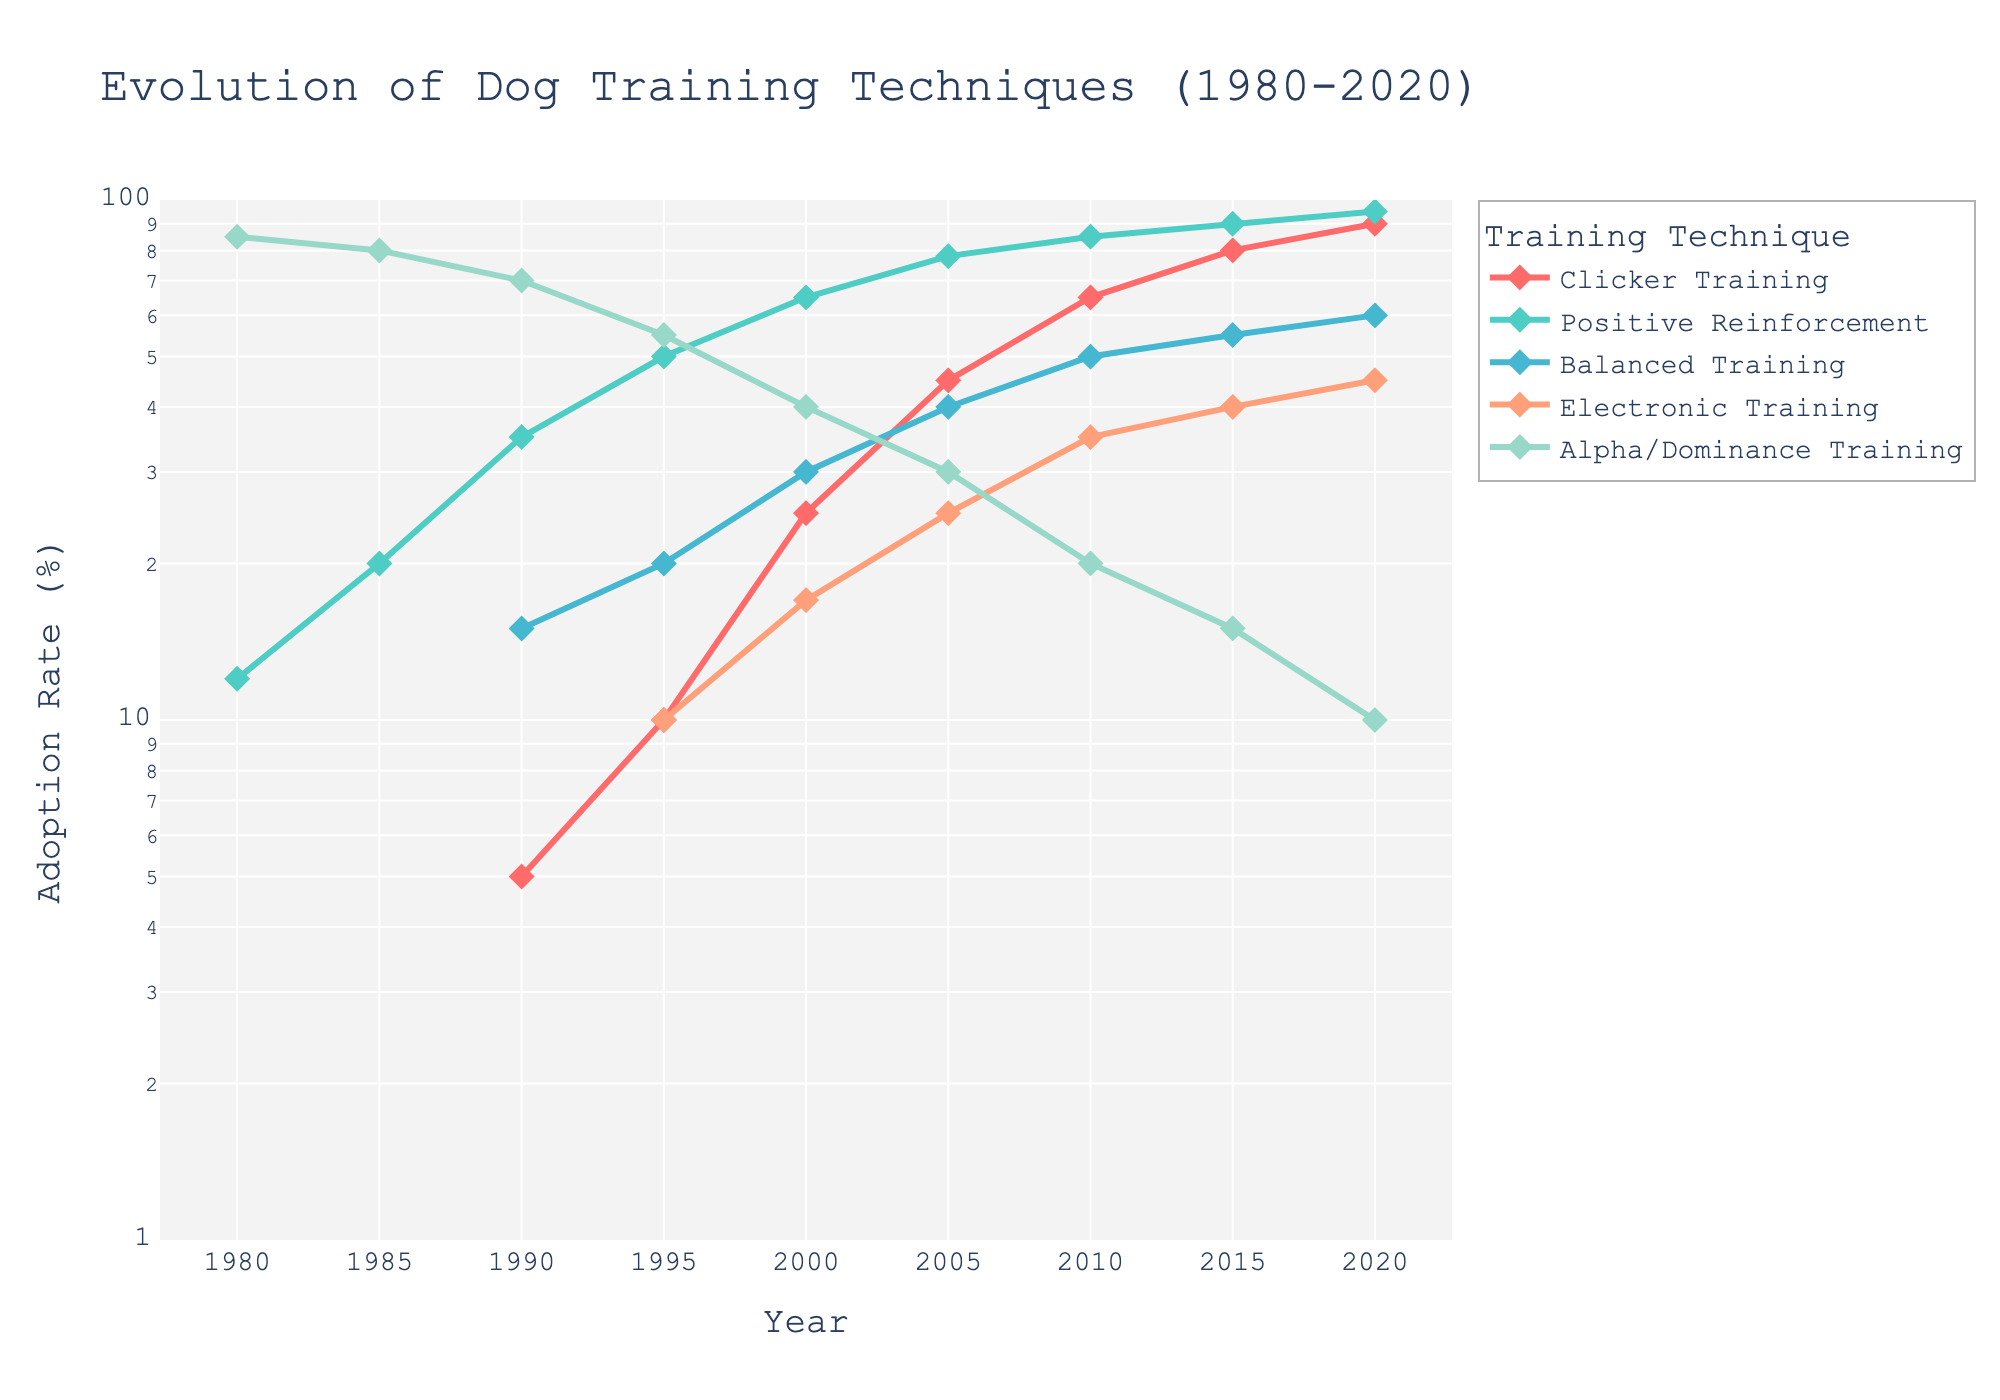How has the adoption rate of Alpha/Dominance Training changed from 1980 to 2020? The adoption rate of Alpha/Dominance Training in 1980 was 85%, and it gradually decreased over the years, reaching 10% in 2020.
Answer: Decreased significantly from 85% to 10% Which training technique had the highest adoption rate in 1990? In the year 1990, Alpha/Dominance Training had the highest adoption rate among the techniques, with an adoption rate of 70%.
Answer: Alpha/Dominance Training Which training technique had the fastest growth in adoption rate between 1990 and 2020? The adoption rate for Clicker Training increased from 5% in 1990 to 90% in 2020, showing the fastest growth among the techniques over this period.
Answer: Clicker Training What was the adoption rate of Positive Reinforcement in 1985 and how does it compare to 2020? The adoption rate of Positive Reinforcement was 20% in 1985, and it increased to 95% in 2020, showing a significant rise in popularity.
Answer: Increased from 20% to 95% Which training techniques had an adoption rate above 50% in 2020? In 2020, Positive Reinforcement, Clicker Training, and Balanced Training had adoption rates above 50%.
Answer: Positive Reinforcement, Clicker Training, and Balanced Training Describe the trend in the adoption rate for Electronic Training from 1995 to 2020. The adoption rate for Electronic Training increased steadily from 10% in 1995 to 45% in 2020, showing a gradual upward trend.
Answer: Steadily increased from 10% to 45% How does the adoption rate of Balanced Training in 2015 compare to Alpha/Dominance Training in the same year? In 2015, Balanced Training had an adoption rate of 55%, while Alpha/Dominance Training had an adoption rate of 15%, indicating that Balanced Training was more popular that year.
Answer: Balanced Training was more popular at 55% vs 15% What percentage point change did Positive Reinforcement see from 2000 to 2020? Positive Reinforcement's adoption rate increased from 65% in 2000 to 95% in 2020, resulting in a 30 percentage point increase.
Answer: 30 percentage points Which technique showed a decline in adoption rate from 1980 to 2020? Alpha/Dominance Training showed a decline in adoption rate, decreasing from 85% in 1980 to 10% in 2020.
Answer: Alpha/Dominance Training What is the overall trend for Clicker Training from 1990 to 2020? Clicker Training showed a significant upward trend, increasing from 5% adoption rate in 1990 to 90% in 2020.
Answer: Significant upward trend 